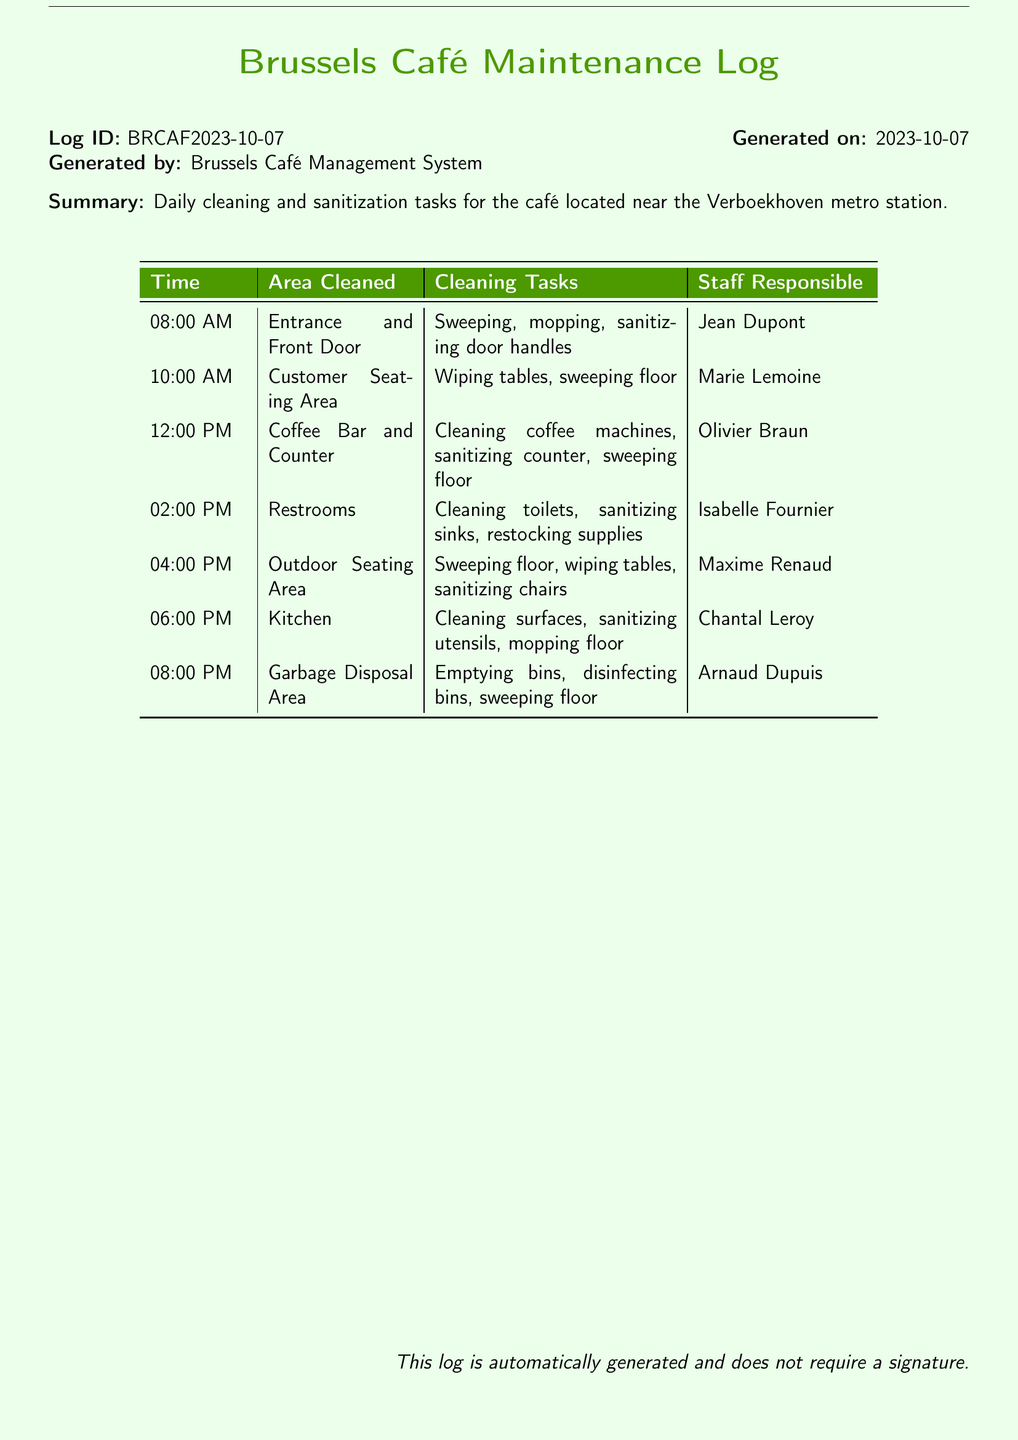What time was the entrance and front door cleaned? The cleaning of the entrance and front door occurred at 08:00 AM.
Answer: 08:00 AM Who was responsible for cleaning the kitchen? The kitchen cleaning was performed by Chantal Leroy.
Answer: Chantal Leroy What area was cleaned at 12:00 PM? At 12:00 PM, the coffee bar and counter were cleaned.
Answer: Coffee Bar and Counter How many cleaning tasks were performed in the customer seating area? In the customer seating area, two tasks were performed: wiping tables and sweeping the floor.
Answer: Two What was the last area cleaned according to the log? The last area cleaned was the garbage disposal area.
Answer: Garbage Disposal Area Which staff member cleaned the restrooms? Isabelle Fournier was responsible for cleaning the restrooms.
Answer: Isabelle Fournier What cleaning task was done at 04:00 PM? Sweeping the floor was one of the tasks done at 04:00 PM.
Answer: Sweeping floor How many total cleaning time entries are listed? There are a total of seven cleaning time entries listed in the log.
Answer: Seven What type of document is this? This document is a maintenance log for cleaning and sanitization records.
Answer: Maintenance log 